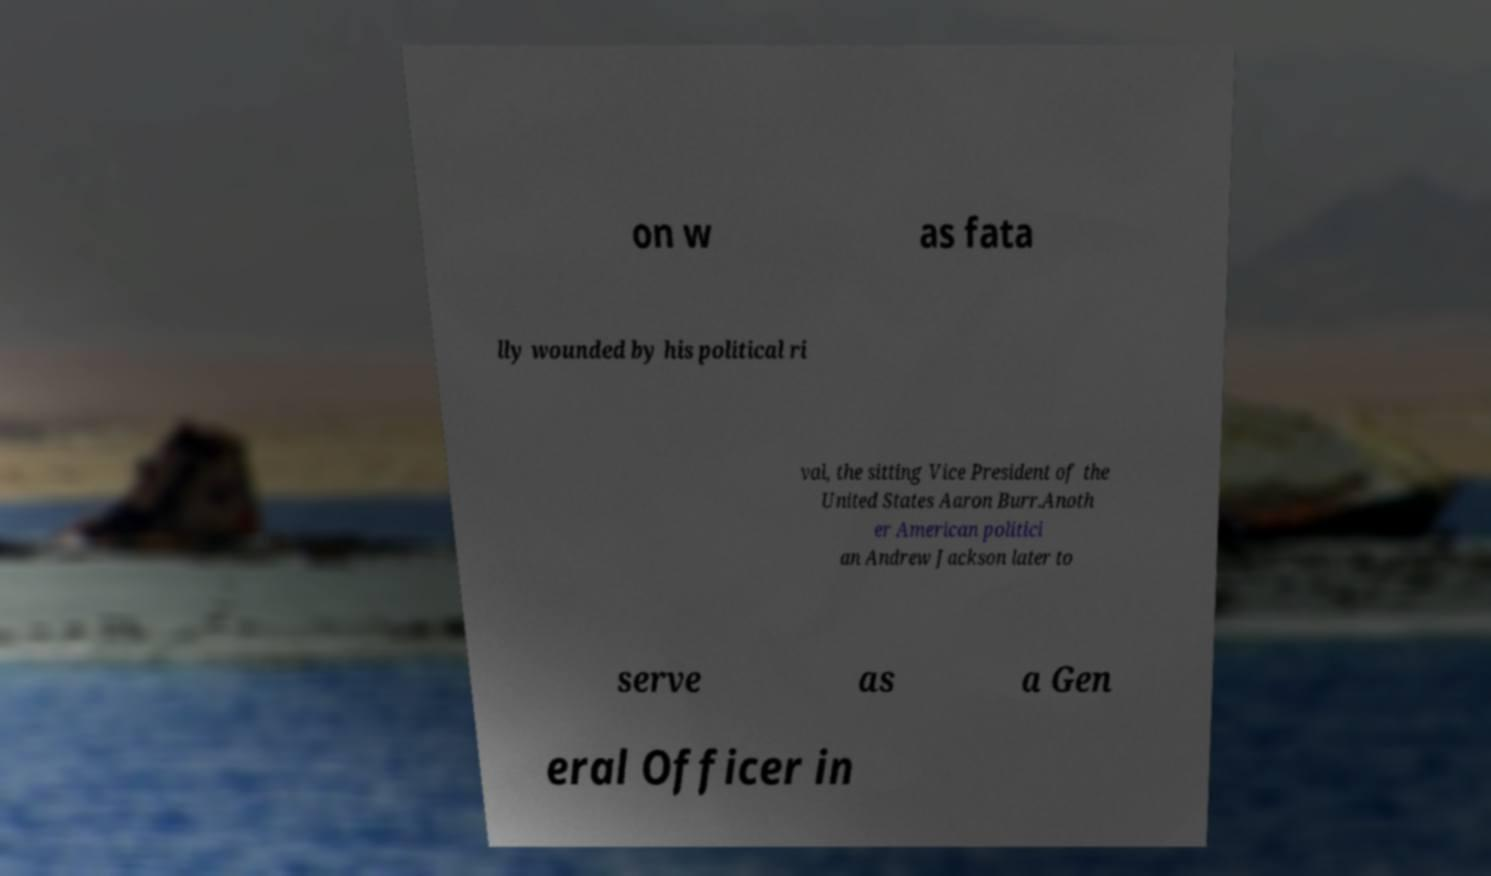What messages or text are displayed in this image? I need them in a readable, typed format. on w as fata lly wounded by his political ri val, the sitting Vice President of the United States Aaron Burr.Anoth er American politici an Andrew Jackson later to serve as a Gen eral Officer in 